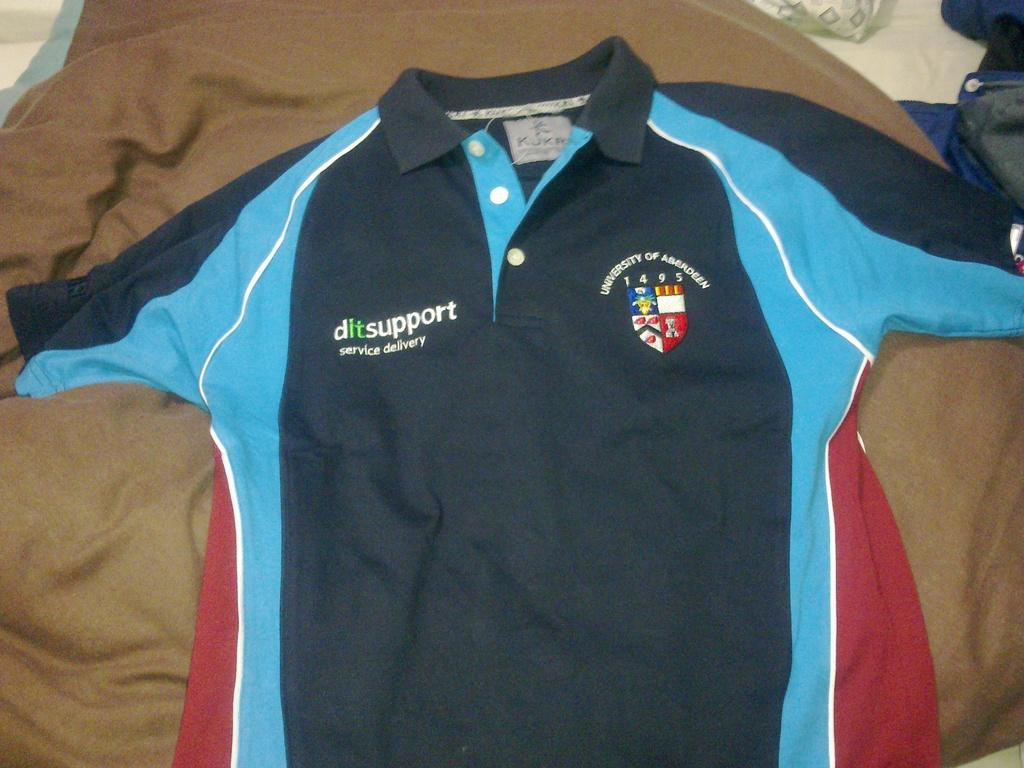<image>
Offer a succinct explanation of the picture presented. A University of Aberdeen jersey is laid out on someones bed. 